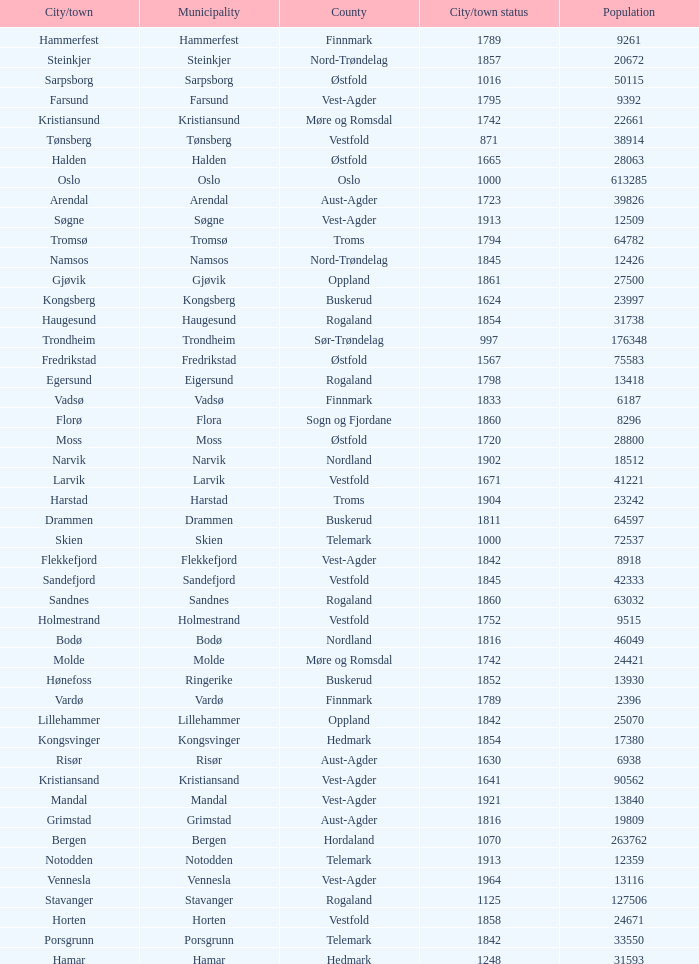What is the total population in the city/town of Arendal? 1.0. 